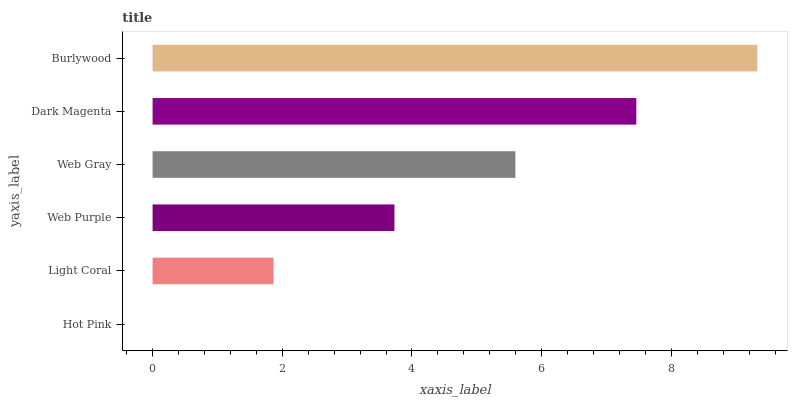Is Hot Pink the minimum?
Answer yes or no. Yes. Is Burlywood the maximum?
Answer yes or no. Yes. Is Light Coral the minimum?
Answer yes or no. No. Is Light Coral the maximum?
Answer yes or no. No. Is Light Coral greater than Hot Pink?
Answer yes or no. Yes. Is Hot Pink less than Light Coral?
Answer yes or no. Yes. Is Hot Pink greater than Light Coral?
Answer yes or no. No. Is Light Coral less than Hot Pink?
Answer yes or no. No. Is Web Gray the high median?
Answer yes or no. Yes. Is Web Purple the low median?
Answer yes or no. Yes. Is Hot Pink the high median?
Answer yes or no. No. Is Dark Magenta the low median?
Answer yes or no. No. 